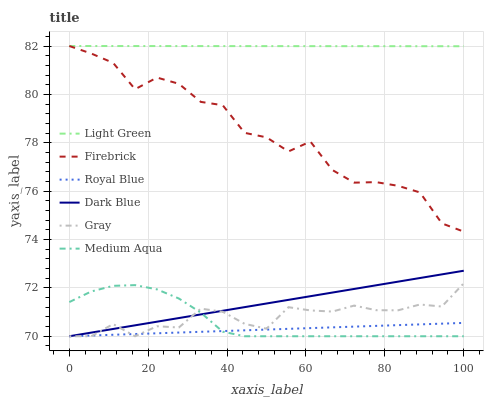Does Royal Blue have the minimum area under the curve?
Answer yes or no. Yes. Does Light Green have the maximum area under the curve?
Answer yes or no. Yes. Does Dark Blue have the minimum area under the curve?
Answer yes or no. No. Does Dark Blue have the maximum area under the curve?
Answer yes or no. No. Is Light Green the smoothest?
Answer yes or no. Yes. Is Firebrick the roughest?
Answer yes or no. Yes. Is Dark Blue the smoothest?
Answer yes or no. No. Is Dark Blue the roughest?
Answer yes or no. No. Does Gray have the lowest value?
Answer yes or no. Yes. Does Firebrick have the lowest value?
Answer yes or no. No. Does Light Green have the highest value?
Answer yes or no. Yes. Does Dark Blue have the highest value?
Answer yes or no. No. Is Medium Aqua less than Firebrick?
Answer yes or no. Yes. Is Light Green greater than Gray?
Answer yes or no. Yes. Does Royal Blue intersect Medium Aqua?
Answer yes or no. Yes. Is Royal Blue less than Medium Aqua?
Answer yes or no. No. Is Royal Blue greater than Medium Aqua?
Answer yes or no. No. Does Medium Aqua intersect Firebrick?
Answer yes or no. No. 